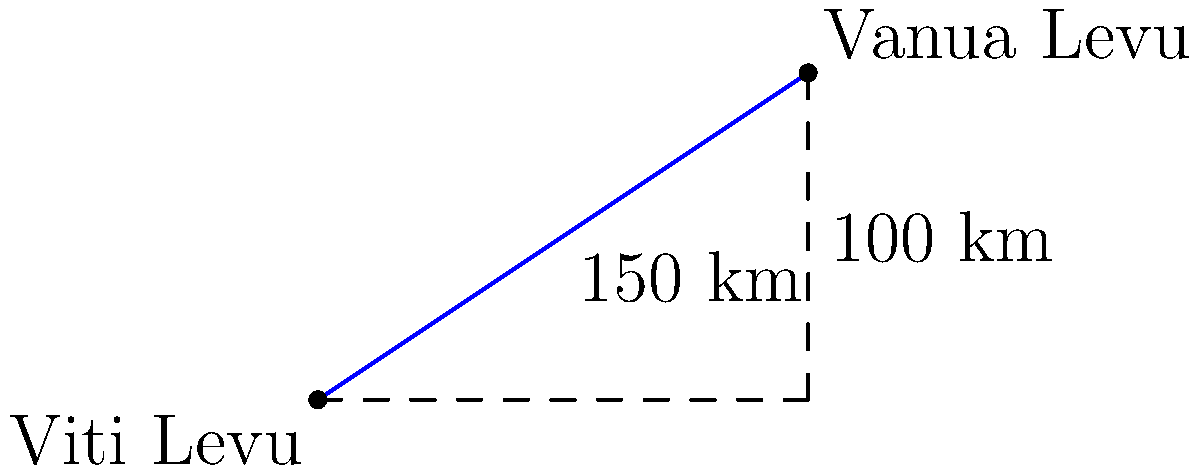Two major Fijian islands, Viti Levu and Vanua Levu, are separated by a strait. Using a coordinate system where Viti Levu is at (0,0) and Vanua Levu is at (150,100) km, calculate the direct distance between these islands using trigonometric ratios. Round your answer to the nearest kilometer. To solve this problem, we can use the Pythagorean theorem, which is a fundamental trigonometric relation.

1) Let's define our right triangle:
   - The base (adjacent side) is 150 km (east-west distance)
   - The height (opposite side) is 100 km (north-south distance)
   - The hypotenuse is the direct distance we're looking for

2) Using the Pythagorean theorem: $a^2 + b^2 = c^2$
   Where $c$ is the hypotenuse (our answer), and $a$ and $b$ are the other two sides.

3) Plugging in our values:
   $150^2 + 100^2 = c^2$

4) Simplify:
   $22500 + 10000 = c^2$
   $32500 = c^2$

5) Take the square root of both sides:
   $\sqrt{32500} = c$

6) Calculate:
   $c \approx 180.2775$ km

7) Rounding to the nearest kilometer:
   $c \approx 180$ km

Therefore, the direct distance between Viti Levu and Vanua Levu is approximately 180 km.
Answer: 180 km 